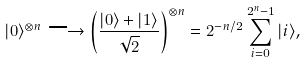Convert formula to latex. <formula><loc_0><loc_0><loc_500><loc_500>| 0 \rangle ^ { \otimes n } \longrightarrow \left ( \frac { | 0 \rangle + | 1 \rangle } { \sqrt { 2 } } \right ) ^ { \otimes n } = 2 ^ { - n / 2 } \sum _ { i = 0 } ^ { 2 ^ { n } - 1 } | i \rangle ,</formula> 